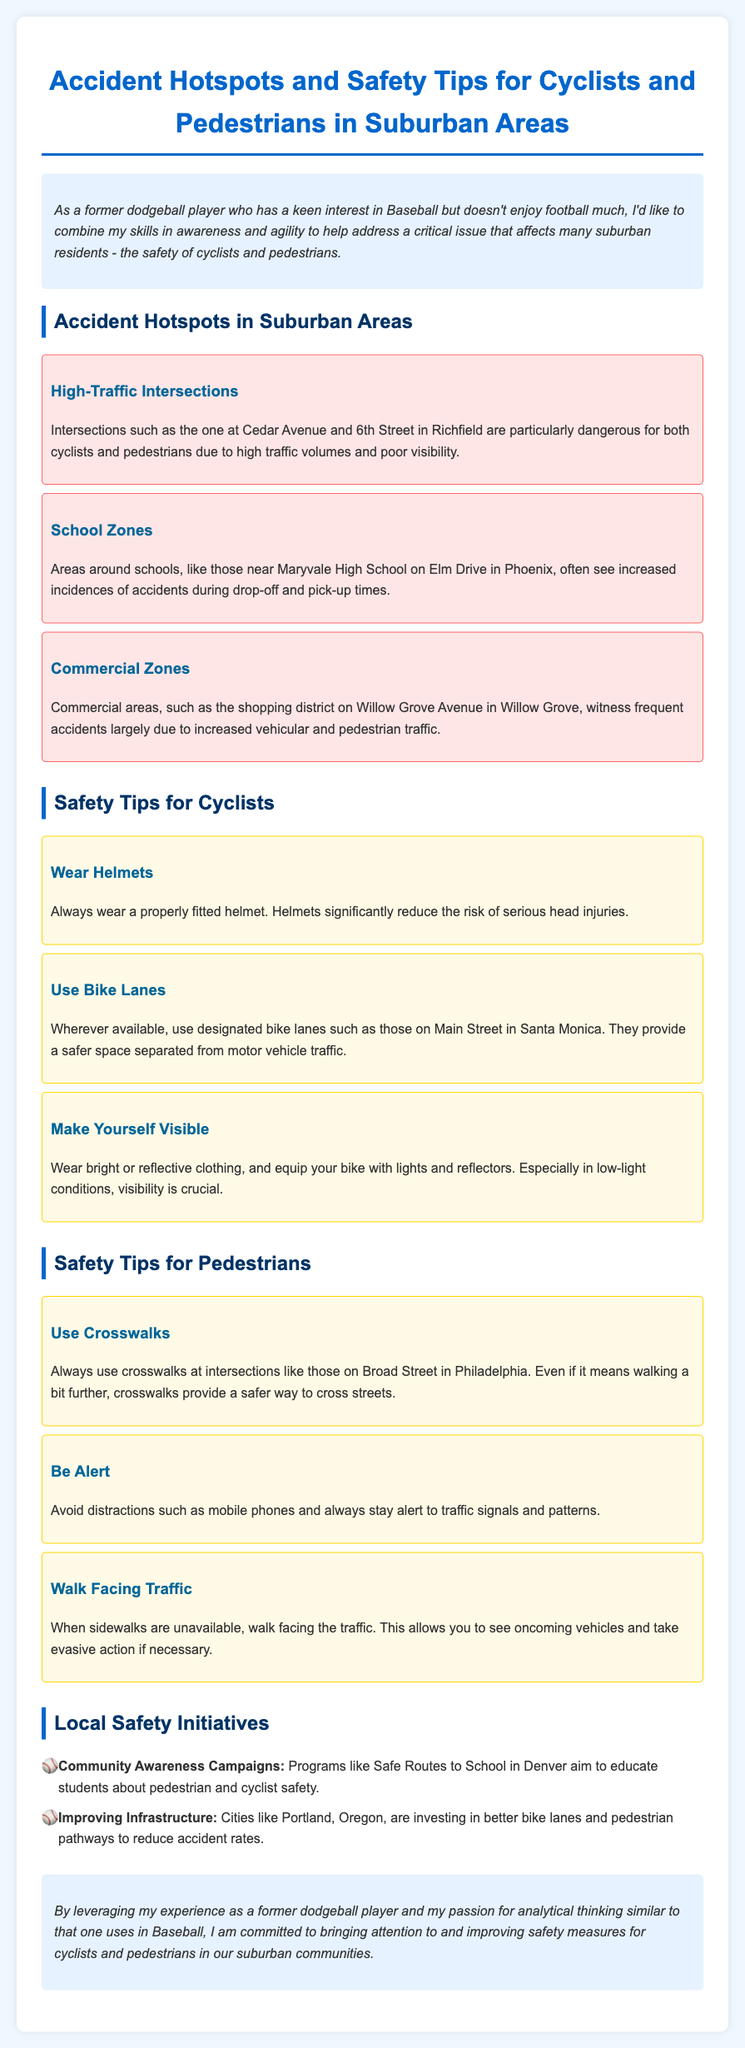What is the first accident hotspot listed? The first accident hotspot mentioned is a high-traffic intersection.
Answer: High-Traffic Intersections What area is noted for dangerous conditions during school times? The area around Maryvale High School experiences increased accidents during drop-off and pick-up times.
Answer: Maryvale High School Which safety tip emphasizes wearing proper headgear? The safety tip that emphasizes wearing proper headgear mentions wearing a helmet.
Answer: Wear Helmets What color clothing should cyclists wear for better visibility? Cyclists should wear bright or reflective clothing for better visibility.
Answer: Bright or reflective What safety initiative is mentioned related to schools? The community awareness campaign for schools mentioned is called Safe Routes to School.
Answer: Safe Routes to School What should pedestrians do at intersections to ensure safety? Pedestrians should use crosswalks at intersections to ensure safety.
Answer: Use crosswalks In which city is the initiative improving bike lanes noted? The initiative improving bike lanes is noted in Portland, Oregon.
Answer: Portland, Oregon What advice is given regarding distractions for pedestrians? Pedestrians are advised to avoid distractions, such as mobile phones.
Answer: Avoid distractions What type of report is this document classified as? This document is classified as a traffic safety report.
Answer: Traffic safety report 